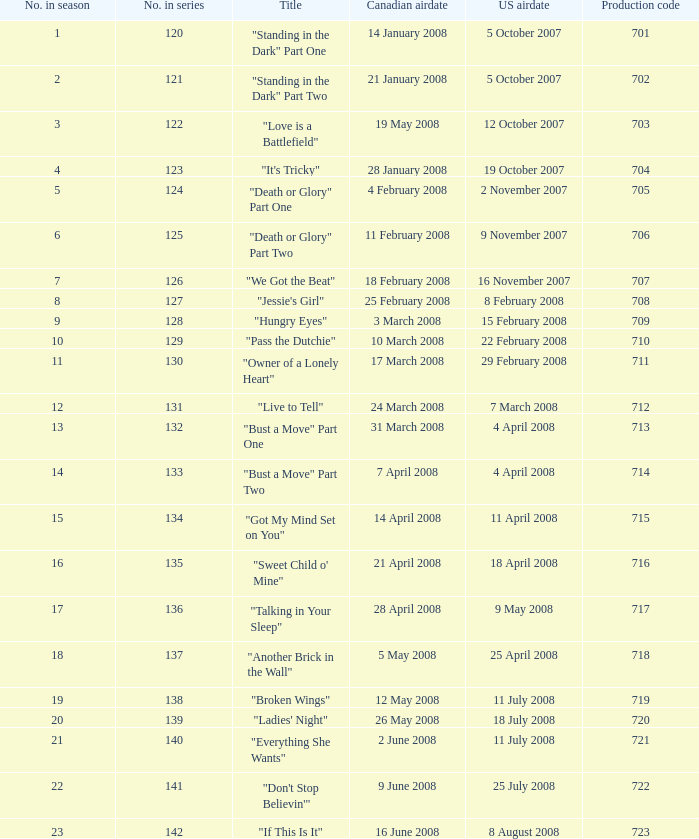What production code corresponds to the u.s. airdate on april 4, 2008? 714.0. Help me parse the entirety of this table. {'header': ['No. in season', 'No. in series', 'Title', 'Canadian airdate', 'US airdate', 'Production code'], 'rows': [['1', '120', '"Standing in the Dark" Part One', '14 January 2008', '5 October 2007', '701'], ['2', '121', '"Standing in the Dark" Part Two', '21 January 2008', '5 October 2007', '702'], ['3', '122', '"Love is a Battlefield"', '19 May 2008', '12 October 2007', '703'], ['4', '123', '"It\'s Tricky"', '28 January 2008', '19 October 2007', '704'], ['5', '124', '"Death or Glory" Part One', '4 February 2008', '2 November 2007', '705'], ['6', '125', '"Death or Glory" Part Two', '11 February 2008', '9 November 2007', '706'], ['7', '126', '"We Got the Beat"', '18 February 2008', '16 November 2007', '707'], ['8', '127', '"Jessie\'s Girl"', '25 February 2008', '8 February 2008', '708'], ['9', '128', '"Hungry Eyes"', '3 March 2008', '15 February 2008', '709'], ['10', '129', '"Pass the Dutchie"', '10 March 2008', '22 February 2008', '710'], ['11', '130', '"Owner of a Lonely Heart"', '17 March 2008', '29 February 2008', '711'], ['12', '131', '"Live to Tell"', '24 March 2008', '7 March 2008', '712'], ['13', '132', '"Bust a Move" Part One', '31 March 2008', '4 April 2008', '713'], ['14', '133', '"Bust a Move" Part Two', '7 April 2008', '4 April 2008', '714'], ['15', '134', '"Got My Mind Set on You"', '14 April 2008', '11 April 2008', '715'], ['16', '135', '"Sweet Child o\' Mine"', '21 April 2008', '18 April 2008', '716'], ['17', '136', '"Talking in Your Sleep"', '28 April 2008', '9 May 2008', '717'], ['18', '137', '"Another Brick in the Wall"', '5 May 2008', '25 April 2008', '718'], ['19', '138', '"Broken Wings"', '12 May 2008', '11 July 2008', '719'], ['20', '139', '"Ladies\' Night"', '26 May 2008', '18 July 2008', '720'], ['21', '140', '"Everything She Wants"', '2 June 2008', '11 July 2008', '721'], ['22', '141', '"Don\'t Stop Believin\'"', '9 June 2008', '25 July 2008', '722'], ['23', '142', '"If This Is It"', '16 June 2008', '8 August 2008', '723']]} 